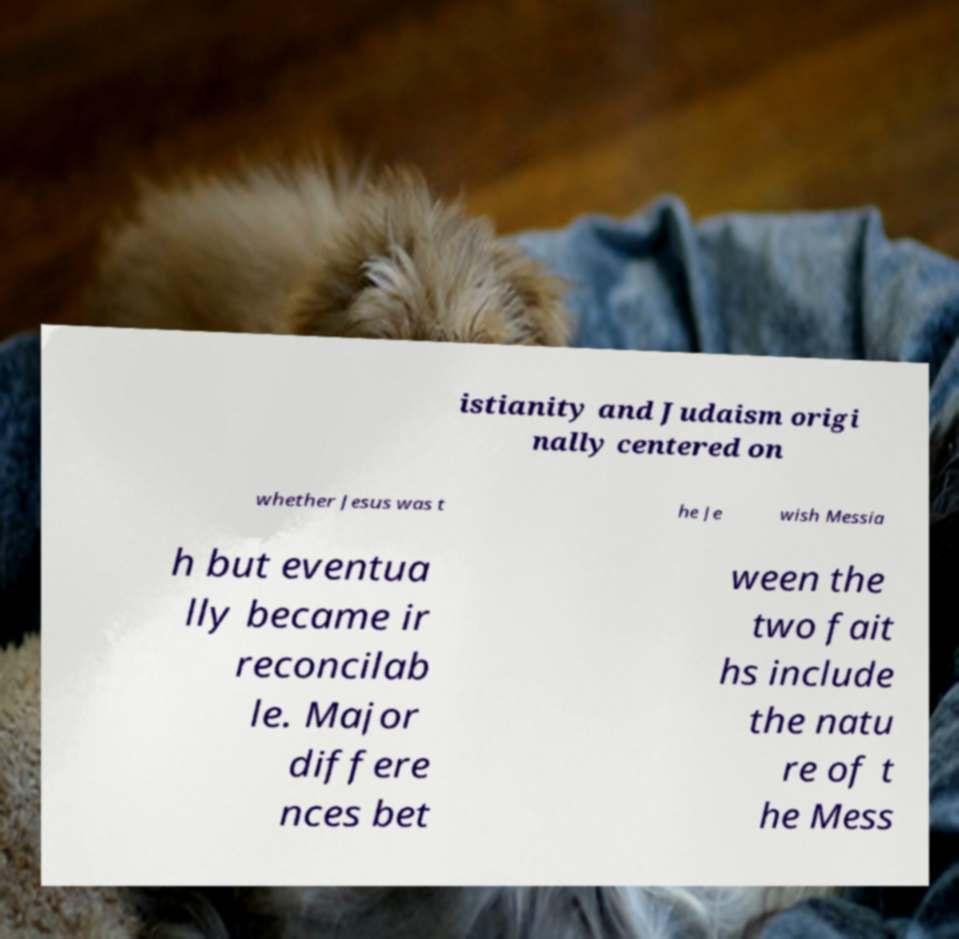Could you assist in decoding the text presented in this image and type it out clearly? istianity and Judaism origi nally centered on whether Jesus was t he Je wish Messia h but eventua lly became ir reconcilab le. Major differe nces bet ween the two fait hs include the natu re of t he Mess 